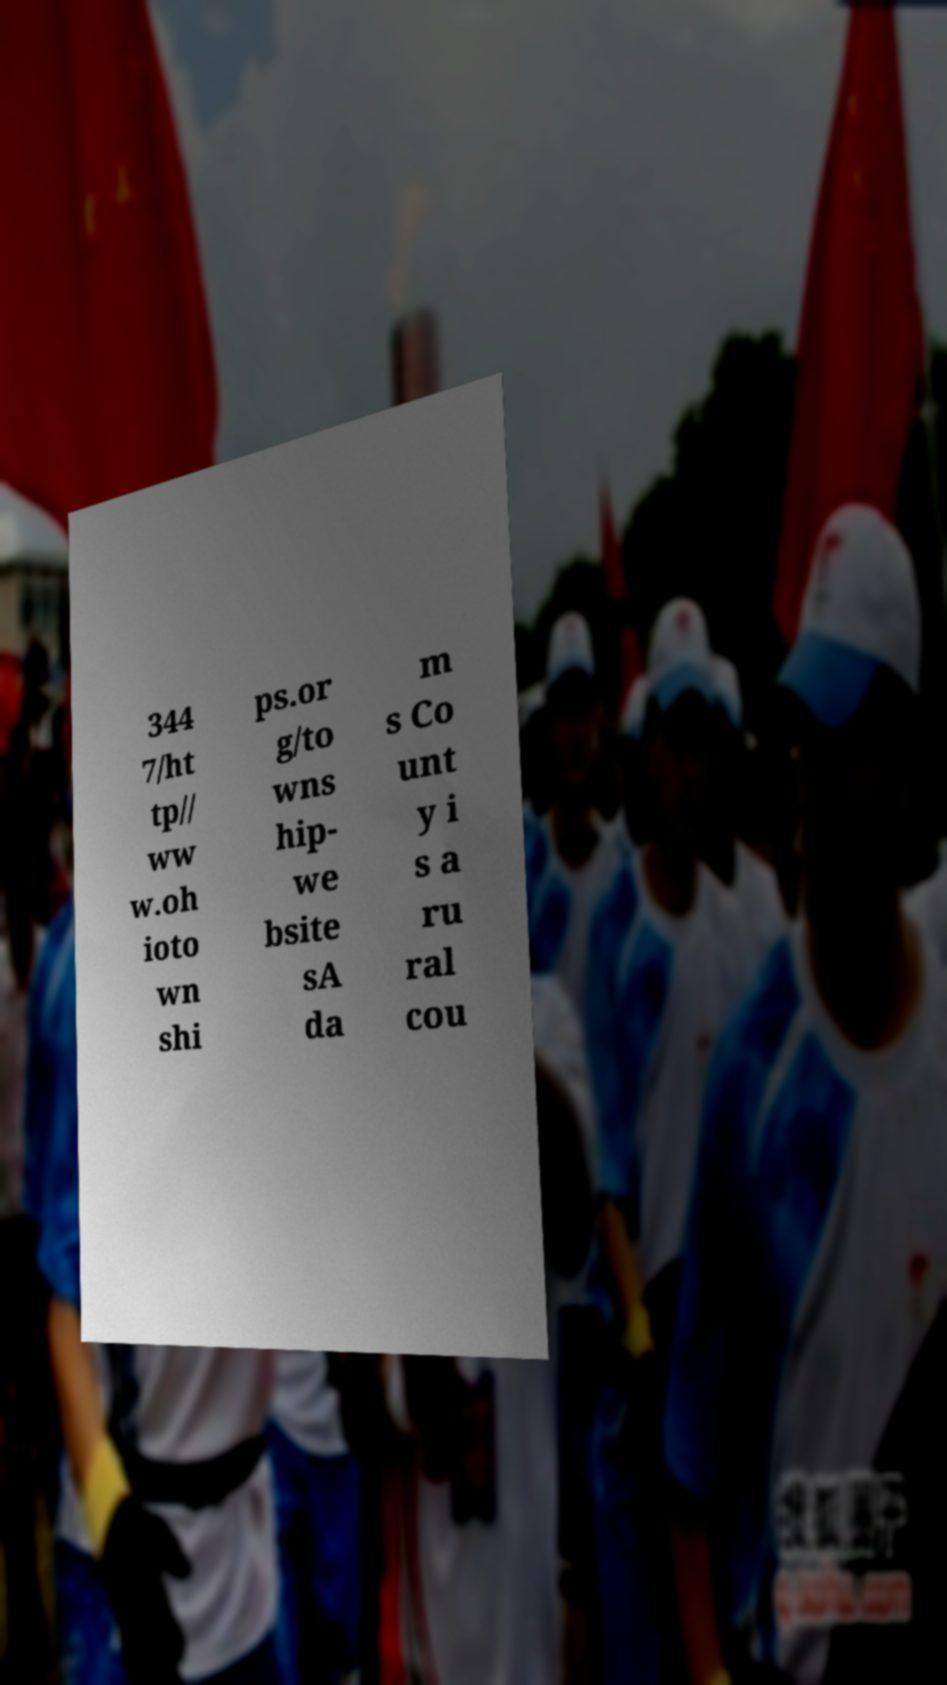Could you assist in decoding the text presented in this image and type it out clearly? 344 7/ht tp// ww w.oh ioto wn shi ps.or g/to wns hip- we bsite sA da m s Co unt y i s a ru ral cou 